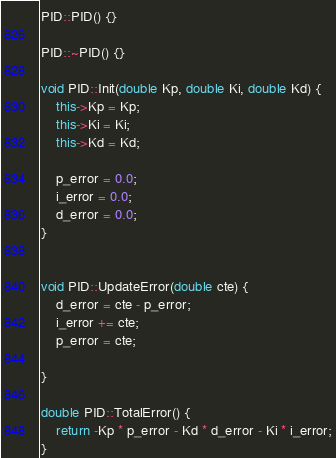Convert code to text. <code><loc_0><loc_0><loc_500><loc_500><_C++_>
PID::PID() {}

PID::~PID() {}

void PID::Init(double Kp, double Ki, double Kd) {
	this->Kp = Kp;
	this->Ki = Ki;
	this->Kd = Kd;

	p_error = 0.0;
	i_error = 0.0;
	d_error = 0.0;
}


void PID::UpdateError(double cte) {
	d_error = cte - p_error;
	i_error += cte;
	p_error = cte;
	
}

double PID::TotalError() {
	return -Kp * p_error - Kd * d_error - Ki * i_error;
}




</code> 